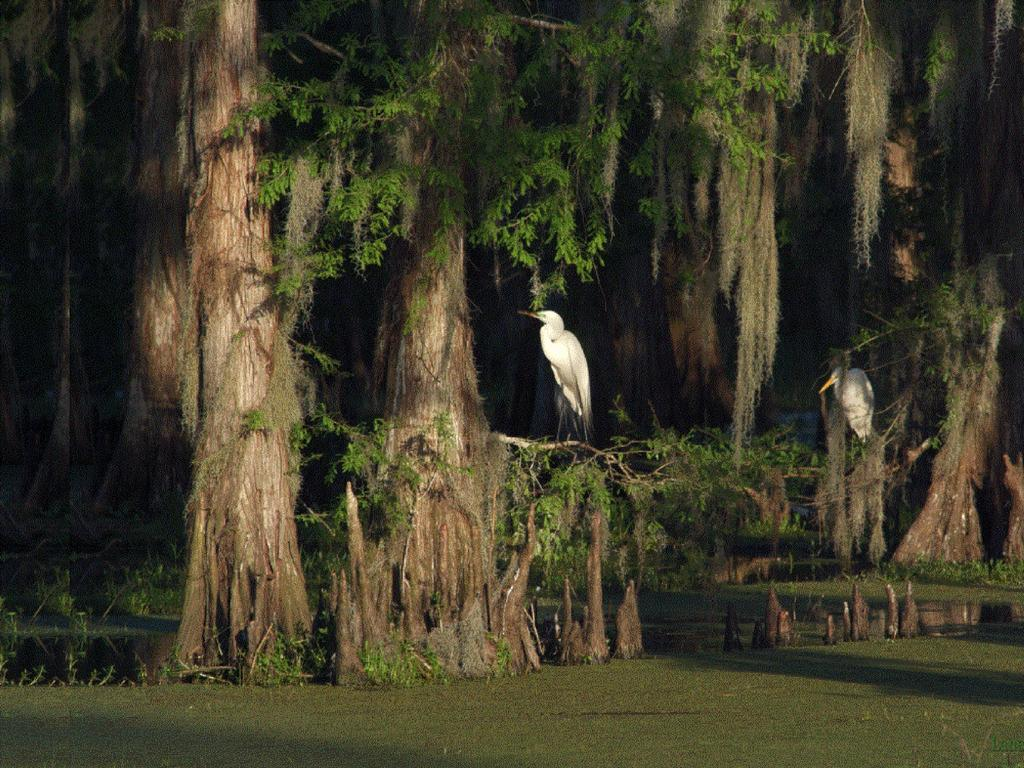What type of vegetation can be seen in the image? There are trees in the image. What animals are present in the image? Cranes are standing on the tree branches. What is the color of the bottom part of the image? The bottom of the image is green in color. What type of waste can be seen on the ground in the image? There is no waste visible on the ground in the image. What mountain range is visible in the background of the image? There is no mountain range present in the image. 